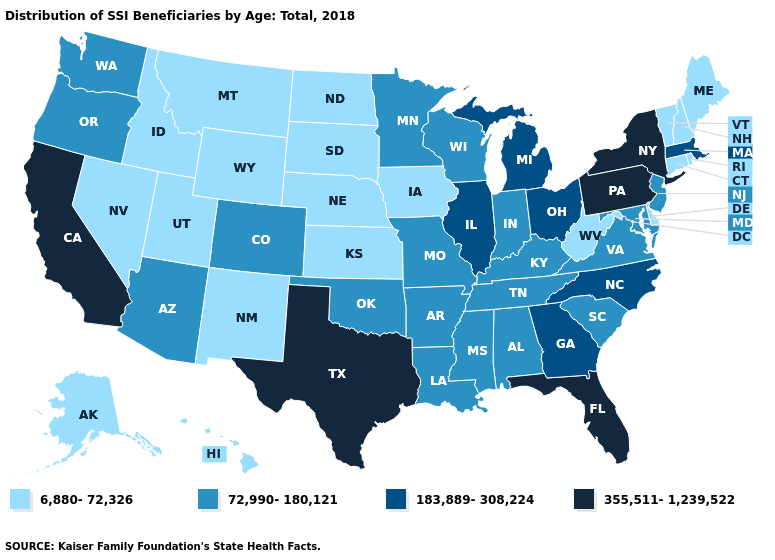What is the highest value in the USA?
Keep it brief. 355,511-1,239,522. What is the value of New Hampshire?
Answer briefly. 6,880-72,326. Name the states that have a value in the range 183,889-308,224?
Keep it brief. Georgia, Illinois, Massachusetts, Michigan, North Carolina, Ohio. What is the value of Massachusetts?
Give a very brief answer. 183,889-308,224. Which states have the lowest value in the USA?
Write a very short answer. Alaska, Connecticut, Delaware, Hawaii, Idaho, Iowa, Kansas, Maine, Montana, Nebraska, Nevada, New Hampshire, New Mexico, North Dakota, Rhode Island, South Dakota, Utah, Vermont, West Virginia, Wyoming. Does Montana have the lowest value in the USA?
Answer briefly. Yes. What is the value of Rhode Island?
Concise answer only. 6,880-72,326. Among the states that border New Jersey , does Delaware have the highest value?
Keep it brief. No. Which states have the lowest value in the Northeast?
Be succinct. Connecticut, Maine, New Hampshire, Rhode Island, Vermont. Does Iowa have a lower value than Tennessee?
Write a very short answer. Yes. What is the lowest value in the MidWest?
Quick response, please. 6,880-72,326. Does South Dakota have the same value as Kentucky?
Quick response, please. No. Which states have the highest value in the USA?
Concise answer only. California, Florida, New York, Pennsylvania, Texas. Does Oklahoma have the highest value in the South?
Short answer required. No. How many symbols are there in the legend?
Answer briefly. 4. 